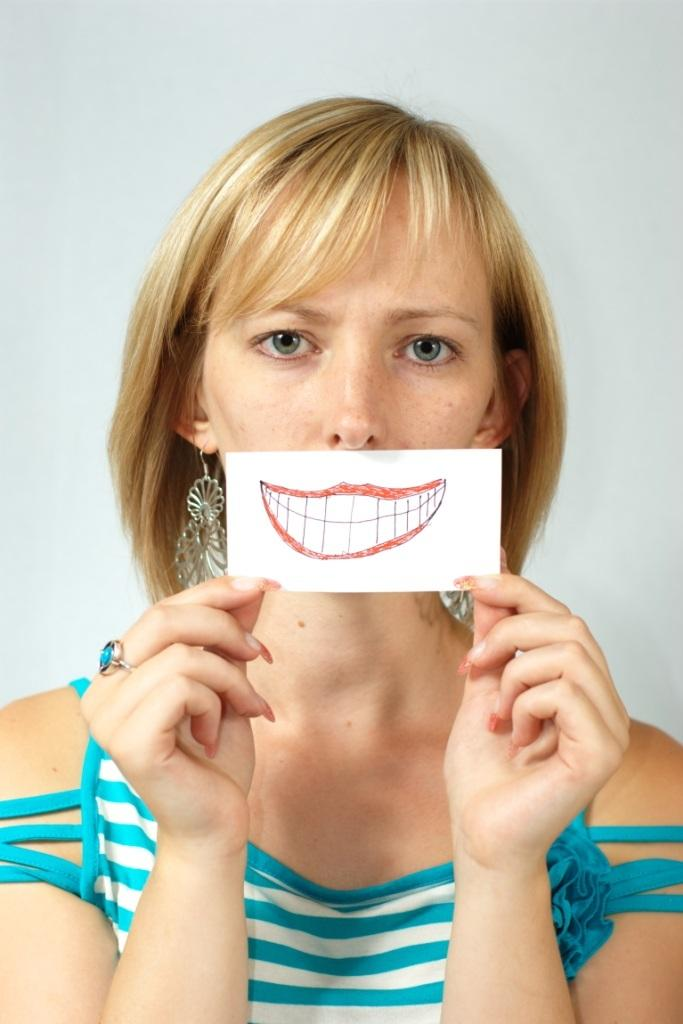Who is the main subject in the image? There is a woman in the image. What is the woman holding in the image? The woman is holding a paper. What is depicted on the paper? The paper contains a painting of a mouth. What is the color of the background in the image? The background of the image is white. What type of secretary can be seen in the image? There is no secretary present in the image; it features a woman holding a paper with a painting of a mouth. What season is depicted in the image? The image does not depict a season; it has a white background and focuses on the woman and the paper she is holding. 